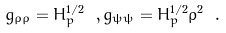Convert formula to latex. <formula><loc_0><loc_0><loc_500><loc_500>g _ { \rho \rho } = H _ { p } ^ { 1 / 2 } \ , g _ { \psi \psi } = H _ { p } ^ { 1 / 2 } \rho ^ { 2 } \ .</formula> 